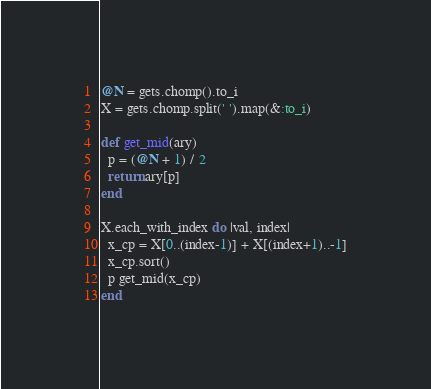Convert code to text. <code><loc_0><loc_0><loc_500><loc_500><_Ruby_>@N = gets.chomp().to_i
X = gets.chomp.split(' ').map(&:to_i)

def get_mid(ary)
  p = (@N + 1) / 2
  return ary[p]
end

X.each_with_index do |val, index|
  x_cp = X[0..(index-1)] + X[(index+1)..-1]
  x_cp.sort()
  p get_mid(x_cp)
end
</code> 